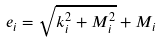<formula> <loc_0><loc_0><loc_500><loc_500>e _ { i } = \sqrt { k _ { i } ^ { 2 } + M _ { i } ^ { 2 } } + M _ { i }</formula> 